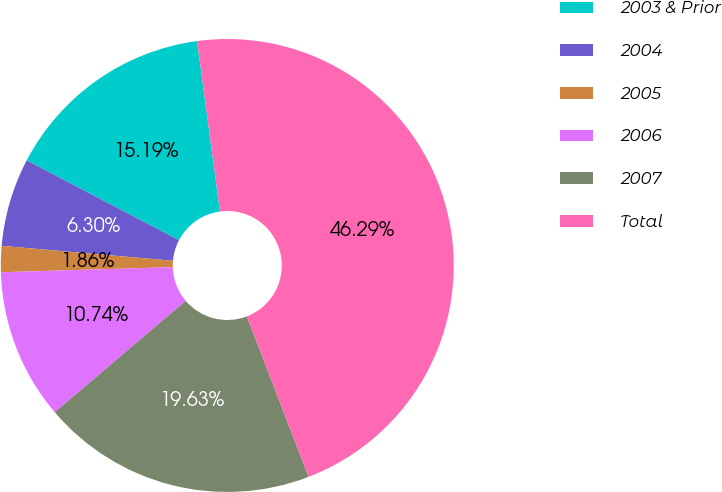<chart> <loc_0><loc_0><loc_500><loc_500><pie_chart><fcel>2003 & Prior<fcel>2004<fcel>2005<fcel>2006<fcel>2007<fcel>Total<nl><fcel>15.19%<fcel>6.3%<fcel>1.86%<fcel>10.74%<fcel>19.63%<fcel>46.29%<nl></chart> 